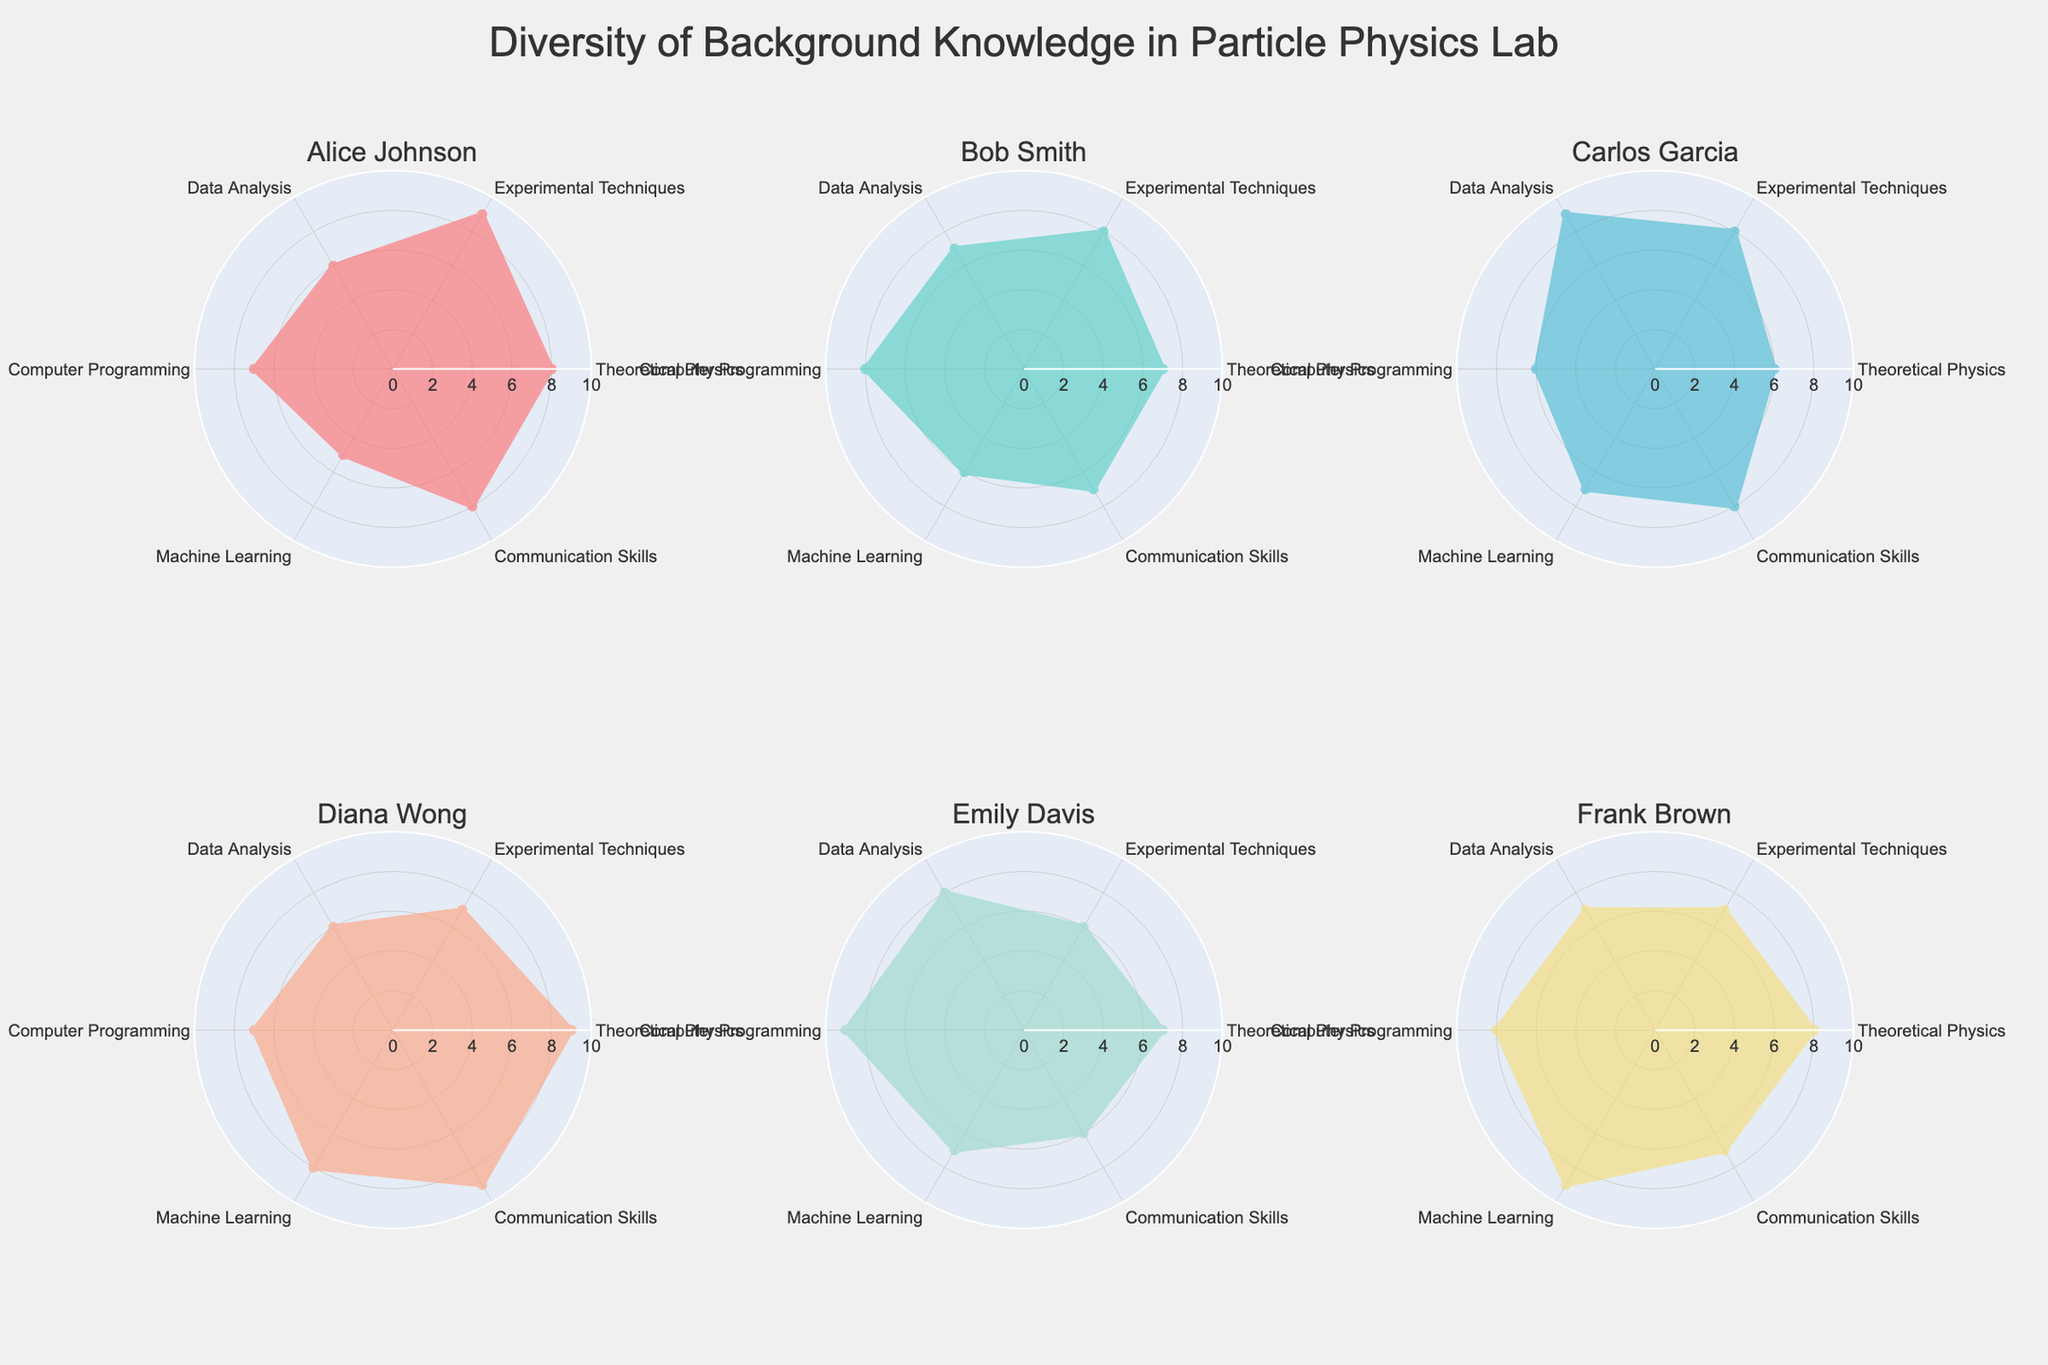What are the names of the team members shown in the radar charts? Each subplot in the figure has a title with the name of a team member. The names listed are Alice Johnson, Bob Smith, Carlos Garcia, Diana Wong, Emily Davis, and Frank Brown.
Answer: Alice Johnson, Bob Smith, Carlos Garcia, Diana Wong, Emily Davis, Frank Brown Which team member has the highest skill level in Data Analysis? By looking at the radial plot for each team member, Carlos Garcia has the highest value in the Data Analysis category, indicated by the longest extension towards this axis.
Answer: Carlos Garcia What is the average communication skill level of the team members? The communication skill levels for each team member need to be summed and then divided by the number of team members. The sum is 8+7+8+9+6+7=45, and dividing by 6 team members gives 45/6 = 7.5.
Answer: 7.5 Which skill area has the widest range of proficiency across all team members? By comparing the lengths of the axes between the minimum and maximum values for each skill, Communication Skills range from 6 to 9, a range of 3; Theoretical Physics ranges from 6 to 9, also a range of 3; other skills have smaller ranges. Communication Skills and Theoretical Physics both have the widest range.
Answer: Communication Skills, Theoretical Physics Who has the most balanced profile across all skill categories? A balanced profile would exhibit more evenly distributed values along all axes. Bob Smith presents a relatively uniform spread across all skill categories, with values ranging closely from 6 to 8.
Answer: Bob Smith Which person shows the highest skill in Machine Learning? Observing the radial plots, Frank Brown has the highest value in Machine Learning, shown by the radial extension reaching the outermost part of this category.
Answer: Frank Brown Which skill category does Diana Wong exceed most other team members? Diana Wong exceeds most of the team members specifically in Communication Skills with a full score of 9, which is the highest among all the plotted values in this category.
Answer: Communication Skills What is the minimum value in the Experimental Techniques category, and who has it? From the radar charts, the minimum value for Experimental Techniques is 6, which is held by Emily Davis.
Answer: 6, Emily Davis Compare the theoretical physics skill of Alice Johnson and Diana Wong. Who is stronger in this skill? The radar charts show that Alice Johnson and Diana Wong both have a maximum value of 9 in Theoretical Physics, so they are equal in this skill.
Answer: Alice Johnson and Diana Wong are equal If we consider someone proficient if they have 8 or more in a certain skill, how many people are proficient in Experimental Techniques? By reviewing the radar charts, the individuals with 8 or more in Experimental Techniques are Alice Johnson (9), Bob Smith (8), Carlos Garcia (8), and Frank Brown (7 is not proficient), so there are three proficient people.
Answer: 3 